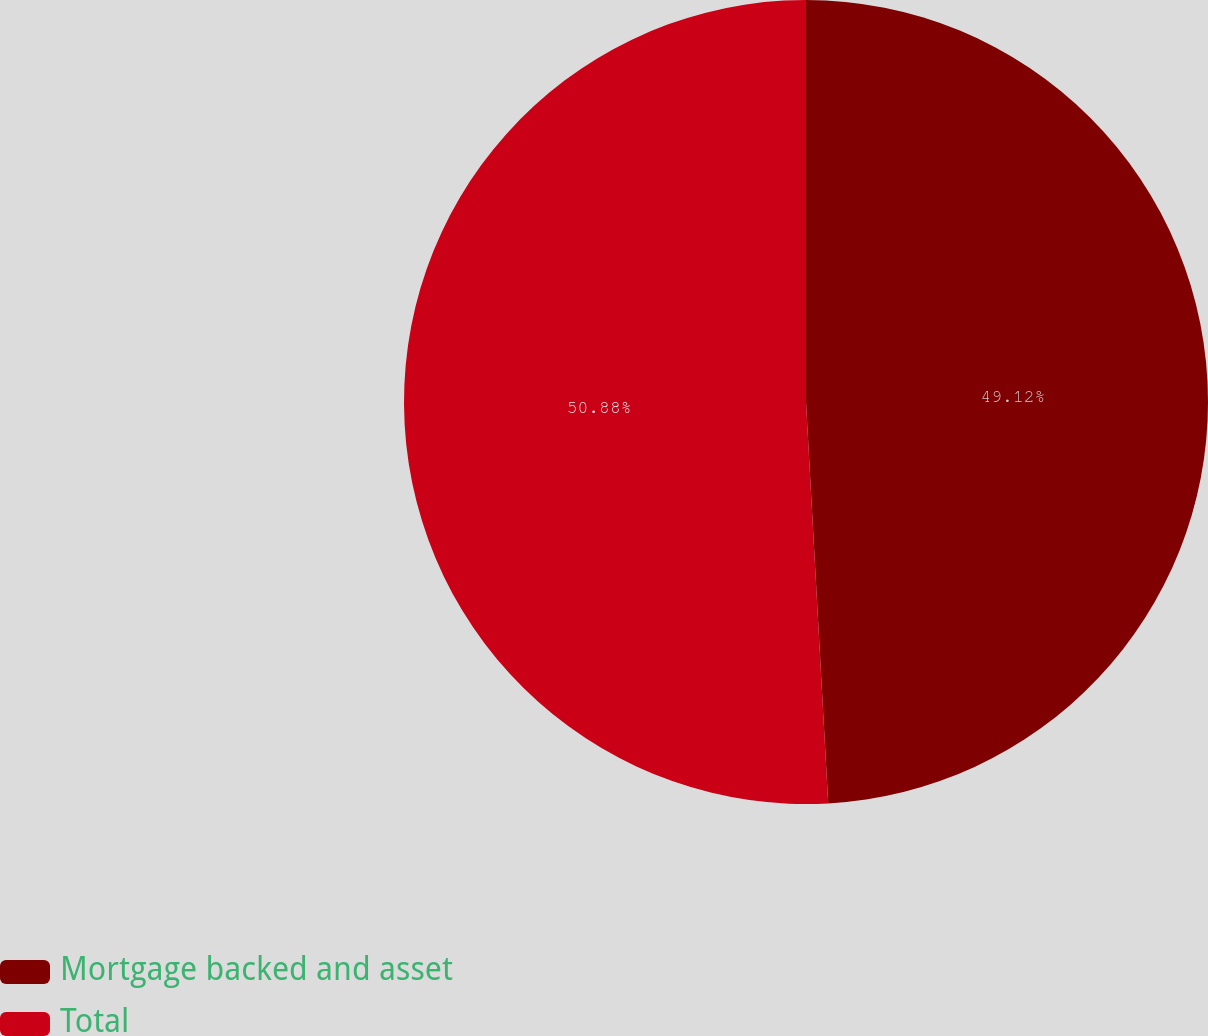Convert chart. <chart><loc_0><loc_0><loc_500><loc_500><pie_chart><fcel>Mortgage backed and asset<fcel>Total<nl><fcel>49.12%<fcel>50.88%<nl></chart> 